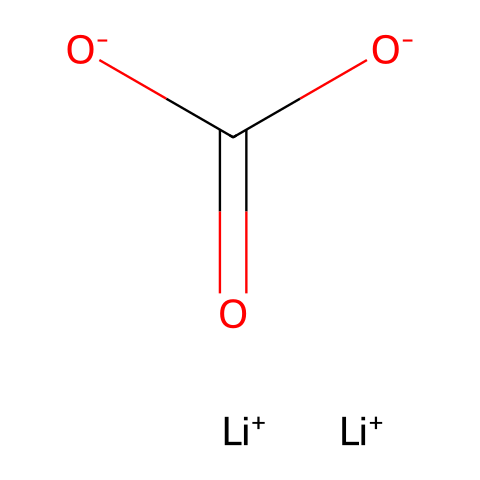What is the molecular formula of lithium carbonate? The chemical structure comprises one lithium ion, one carbonate group characterized by the presence of one carbon atom and three oxygen atoms, leading to the molecular formula Li2CO3.
Answer: Li2CO3 How many lithium ions are present in this structure? The given structure shows two [Li+] units, indicating there are two lithium ions in the formula.
Answer: 2 What type of compound is lithium carbonate classified as? Lithium carbonate is classified as a salt, specifically an inorganic salt due to the ionic bonding between lithium ions and the carbonate ion.
Answer: salt How many oxygen atoms are in lithium carbonate? By analyzing the carbonate ion, which contributes three oxygen atoms, the structure presents a total of three oxygen atoms.
Answer: 3 What kind of bonding is primarily involved in lithium carbonate? The primary bonding type in lithium carbonate is ionic bonding, which occurs between lithium ions and the carbonate ion due to their opposite charges.
Answer: ionic What charge does the carbonate ion carry in this structure? The carbonate ion, represented by [O-]C(=O)[O-], carries a net charge of -2, as indicated by the two negatively charged oxygen atoms.
Answer: -2 